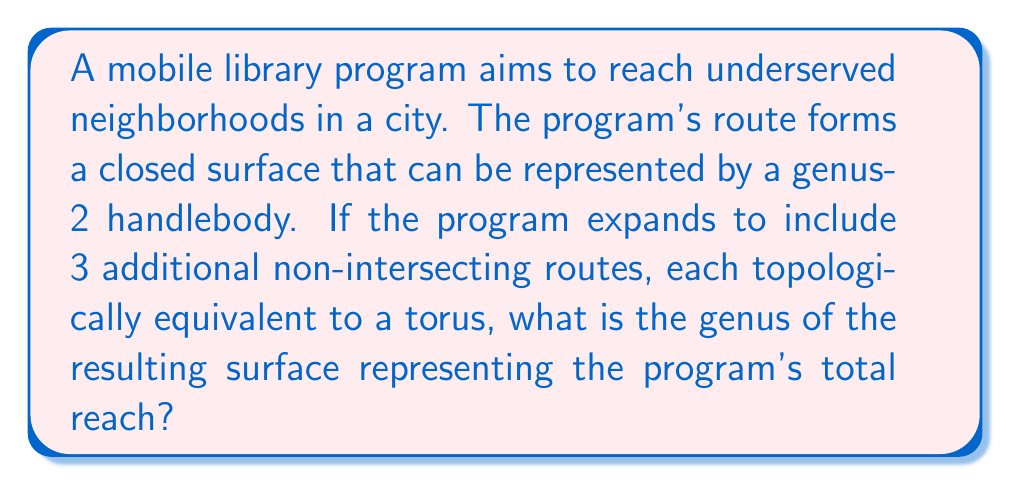Show me your answer to this math problem. Let's approach this step-by-step:

1) We start with a genus-2 handlebody, which represents the initial route of the mobile library program. The genus of this surface is 2.

2) The program then adds 3 additional routes, each topologically equivalent to a torus. A torus has a genus of 1.

3) In knot theory, when we combine surfaces, we add their genera. This is because the genus represents the number of "handles" on a surface.

4) The resulting surface can be represented mathematically as:

   $$G_{total} = G_{initial} + G_{route1} + G_{route2} + G_{route3}$$

   Where $G$ represents the genus of each component.

5) Substituting the known values:

   $$G_{total} = 2 + 1 + 1 + 1$$

6) Simplifying:

   $$G_{total} = 5$$

This result indicates that the final surface representing the total reach of the mobile library program has 5 "handles" or holes, which in topological terms means it has a genus of 5.
Answer: 5 